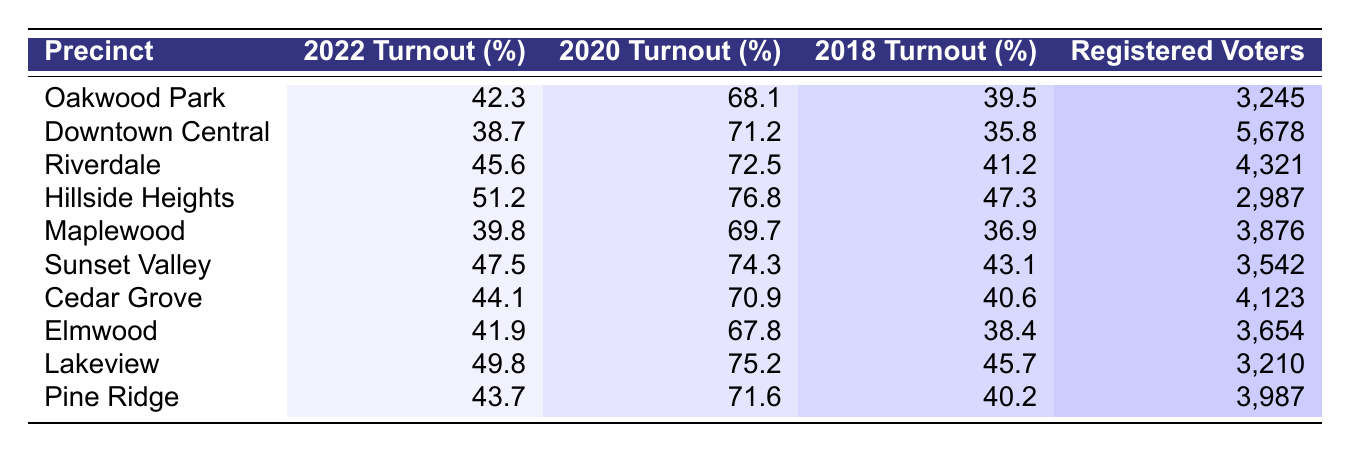What precinct had the highest voter turnout in 2022? By examining the 2022 Turnout (%) column, we find that the highest percentage is 51.2, which corresponds to Hillside Heights.
Answer: Hillside Heights Which precinct had the lowest voter turnout in 2020? Looking at the 2020 Turnout (%) column, Downtown Central has the lowest turnout at 71.2%.
Answer: Downtown Central What is the registered voter count in Sunset Valley? Sunset Valley has 3,542 registered voters, as listed in the Registered Voters column.
Answer: 3,542 What was the turnout difference between 2022 and 2018 for Maplewood? The turnout for Maplewood in 2022 was 39.8%, and in 2018 it was 36.9%. The difference is 39.8 - 36.9 = 2.9%.
Answer: 2.9% What is the average voter turnout for all precincts in 2022? The 2022 Turnout values (42.3, 38.7, 45.6, 51.2, 39.8, 47.5, 44.1, 41.9, 49.8, 43.7) sum to 438.6. Dividing this by the number of precincts (10) gives an average of 43.86%.
Answer: 43.86% Did any precinct have a turnout of over 50% in 2022? From the 2022 Turnout (%) column, Hillside Heights (51.2%) and Lakeview (49.8%) show that there is one precinct (Hillside Heights) with turnout over 50%.
Answer: Yes Which precinct had a higher turnout in 2020, Riverdale or Cedar Grove? Riverdale had a turnout of 72.5% in 2020, while Cedar Grove had 70.9%; therefore, Riverdale had the higher turnout.
Answer: Riverdale What is the difference in registered voters between the precincts with the highest and lowest 2022 turnout? Hillside Heights has 2,987 registered voters (highest 2022 turnout) and Downtown Central has 5,678 (lowest 2022 turnout). The difference is 5,678 - 2,987 = 2,691.
Answer: 2,691 Which precinct had the highest increase in turnout from 2018 to 2020? We calculate the increase for each precinct: Oakwood Park (68.1 - 39.5 = 28.6), Downtown Central (71.2 - 35.8 = 35.4), Riverdale (72.5 - 41.2 = 31.3), etc. Downtown Central had the highest increase of 35.4%.
Answer: Downtown Central Was the 2022 turnout higher than 2020 in any precinct? By comparing the 2022 turnout percentages with the 2020 turnout percentages for all precincts, we find that all precincts had lower 2022 turnout than 2020.
Answer: No 